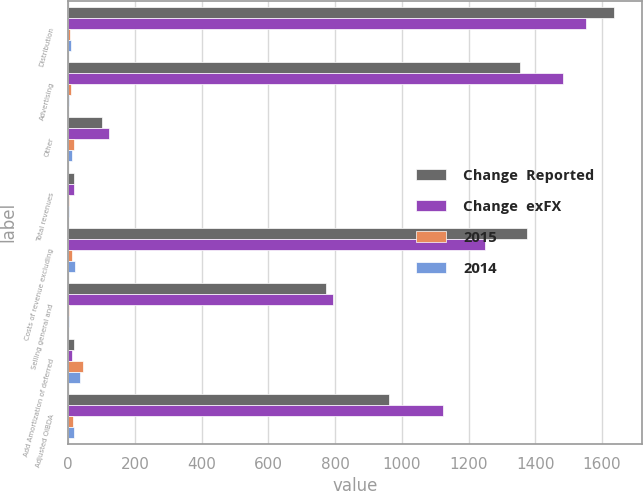Convert chart to OTSL. <chart><loc_0><loc_0><loc_500><loc_500><stacked_bar_chart><ecel><fcel>Distribution<fcel>Advertising<fcel>Other<fcel>Total revenues<fcel>Costs of revenue excluding<fcel>Selling general and<fcel>Add Amortization of deferred<fcel>Adjusted OIBDA<nl><fcel>Change  Reported<fcel>1637<fcel>1353<fcel>102<fcel>17.5<fcel>1375<fcel>772<fcel>16<fcel>961<nl><fcel>Change  exFX<fcel>1553<fcel>1483<fcel>121<fcel>17.5<fcel>1250<fcel>794<fcel>11<fcel>1124<nl><fcel>2015<fcel>5<fcel>9<fcel>16<fcel>2<fcel>10<fcel>3<fcel>45<fcel>15<nl><fcel>2014<fcel>7<fcel>2<fcel>11<fcel>2<fcel>19<fcel>2<fcel>36<fcel>16<nl></chart> 